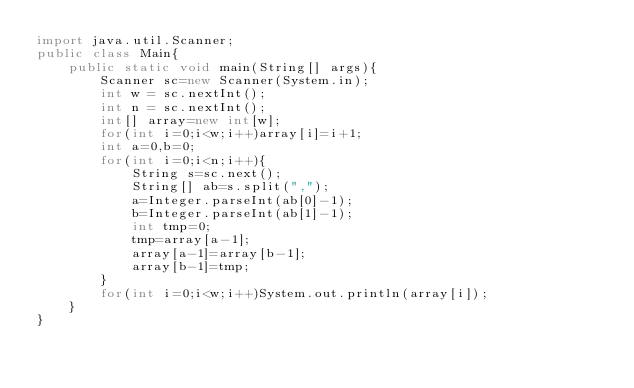Convert code to text. <code><loc_0><loc_0><loc_500><loc_500><_Java_>import java.util.Scanner;
public class Main{
    public static void main(String[] args){
        Scanner sc=new Scanner(System.in);
        int w = sc.nextInt();
        int n = sc.nextInt();
        int[] array=new int[w];
        for(int i=0;i<w;i++)array[i]=i+1;
        int a=0,b=0;
        for(int i=0;i<n;i++){
            String s=sc.next();
            String[] ab=s.split(",");
            a=Integer.parseInt(ab[0]-1);
            b=Integer.parseInt(ab[1]-1);
            int tmp=0;
            tmp=array[a-1];
            array[a-1]=array[b-1];
            array[b-1]=tmp;
        }
        for(int i=0;i<w;i++)System.out.println(array[i]);
    }
}
</code> 